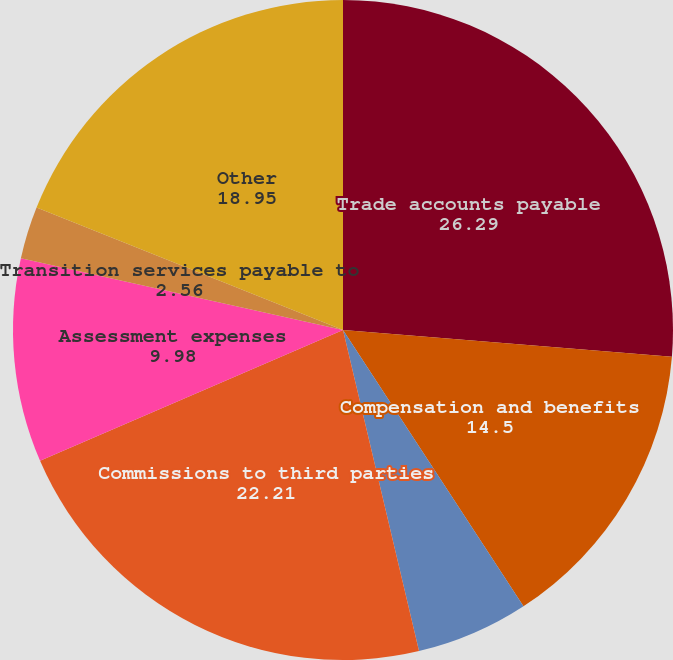<chart> <loc_0><loc_0><loc_500><loc_500><pie_chart><fcel>Trade accounts payable<fcel>Compensation and benefits<fcel>Third party processing<fcel>Commissions to third parties<fcel>Assessment expenses<fcel>Transition services payable to<fcel>Other<nl><fcel>26.29%<fcel>14.5%<fcel>5.51%<fcel>22.21%<fcel>9.98%<fcel>2.56%<fcel>18.95%<nl></chart> 